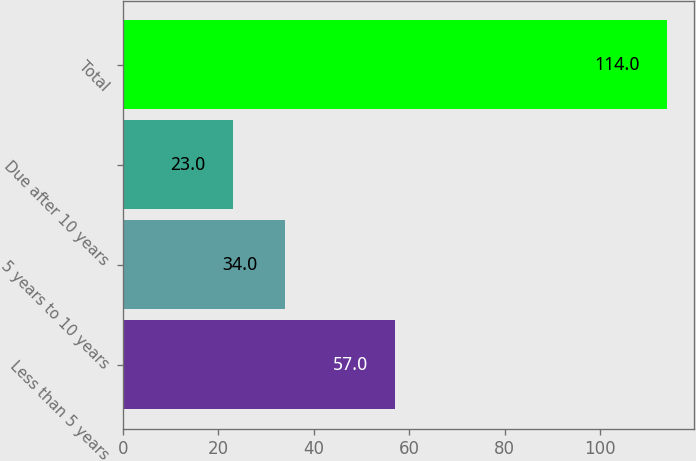<chart> <loc_0><loc_0><loc_500><loc_500><bar_chart><fcel>Less than 5 years<fcel>5 years to 10 years<fcel>Due after 10 years<fcel>Total<nl><fcel>57<fcel>34<fcel>23<fcel>114<nl></chart> 